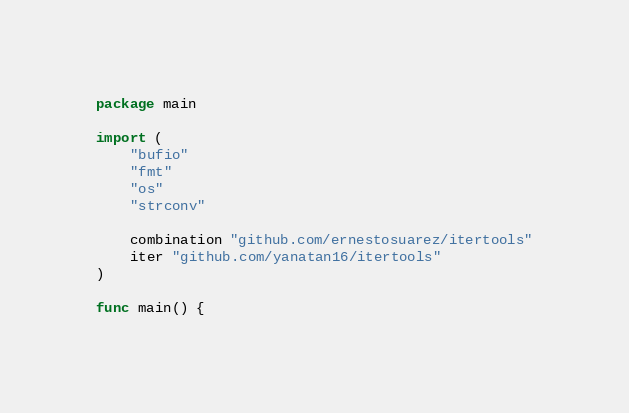<code> <loc_0><loc_0><loc_500><loc_500><_Go_>package main

import (
	"bufio"
	"fmt"
	"os"
	"strconv"

	combination "github.com/ernestosuarez/itertools"
	iter "github.com/yanatan16/itertools"
)

func main() {
</code> 